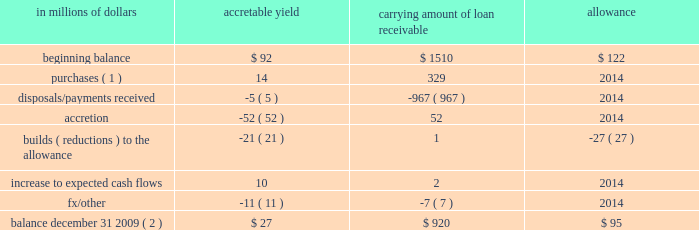In addition , included in the loan table are purchased distressed loans , which are loans that have evidenced significant credit deterioration subsequent to origination but prior to acquisition by citigroup .
In accordance with sop 03-3 , the difference between the total expected cash flows for these loans and the initial recorded investments is recognized in income over the life of the loans using a level yield .
Accordingly , these loans have been excluded from the impaired loan information presented above .
In addition , per sop 03-3 , subsequent decreases to the expected cash flows for a purchased distressed loan require a build of an allowance so the loan retains its level yield .
However , increases in the expected cash flows are first recognized as a reduction of any previously established allowance and then recognized as income prospectively over the remaining life of the loan by increasing the loan 2019s level yield .
Where the expected cash flows cannot be reliably estimated , the purchased distressed loan is accounted for under the cost recovery method .
The carrying amount of the purchased distressed loan portfolio at december 31 , 2009 was $ 825 million net of an allowance of $ 95 million .
The changes in the accretable yield , related allowance and carrying amount net of accretable yield for 2009 are as follows : in millions of dollars accretable carrying amount of loan receivable allowance .
( 1 ) the balance reported in the column 201ccarrying amount of loan receivable 201d consists of $ 87 million of purchased loans accounted for under the level-yield method and $ 242 million under the cost-recovery method .
These balances represent the fair value of these loans at their acquisition date .
The related total expected cash flows for the level-yield loans were $ 101 million at their acquisition dates .
( 2 ) the balance reported in the column 201ccarrying amount of loan receivable 201d consists of $ 561 million of loans accounted for under the level-yield method and $ 359 million accounted for under the cost-recovery method. .
What was the total change in millions of carrying amount of loan receivable? 
Computations: (920 - 1510)
Answer: -590.0. 